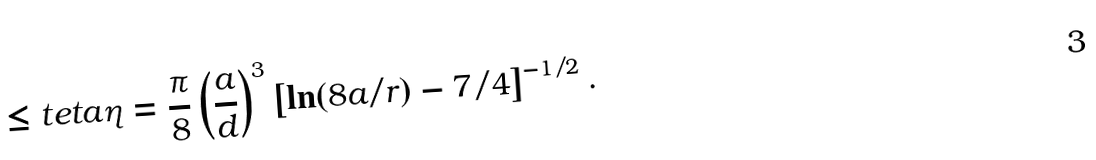Convert formula to latex. <formula><loc_0><loc_0><loc_500><loc_500>\leq t { e t a } \eta = \frac { \pi } { 8 } \left ( \frac { a } { d } \right ) ^ { 3 } \left [ \ln ( 8 a / r ) - 7 / 4 \right ] ^ { - 1 / 2 } .</formula> 